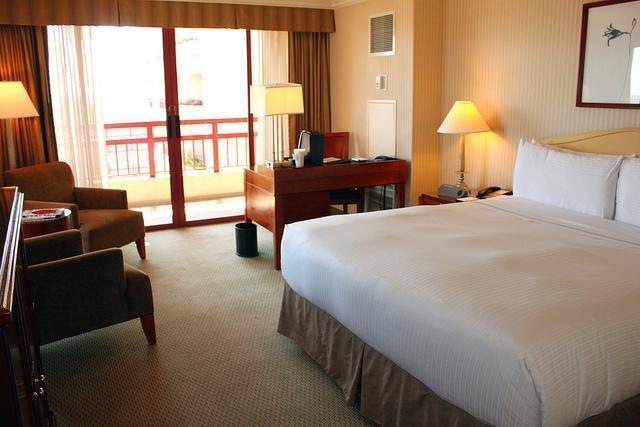How many chairs are visible?
Give a very brief answer. 2. How many couches are there?
Give a very brief answer. 2. 